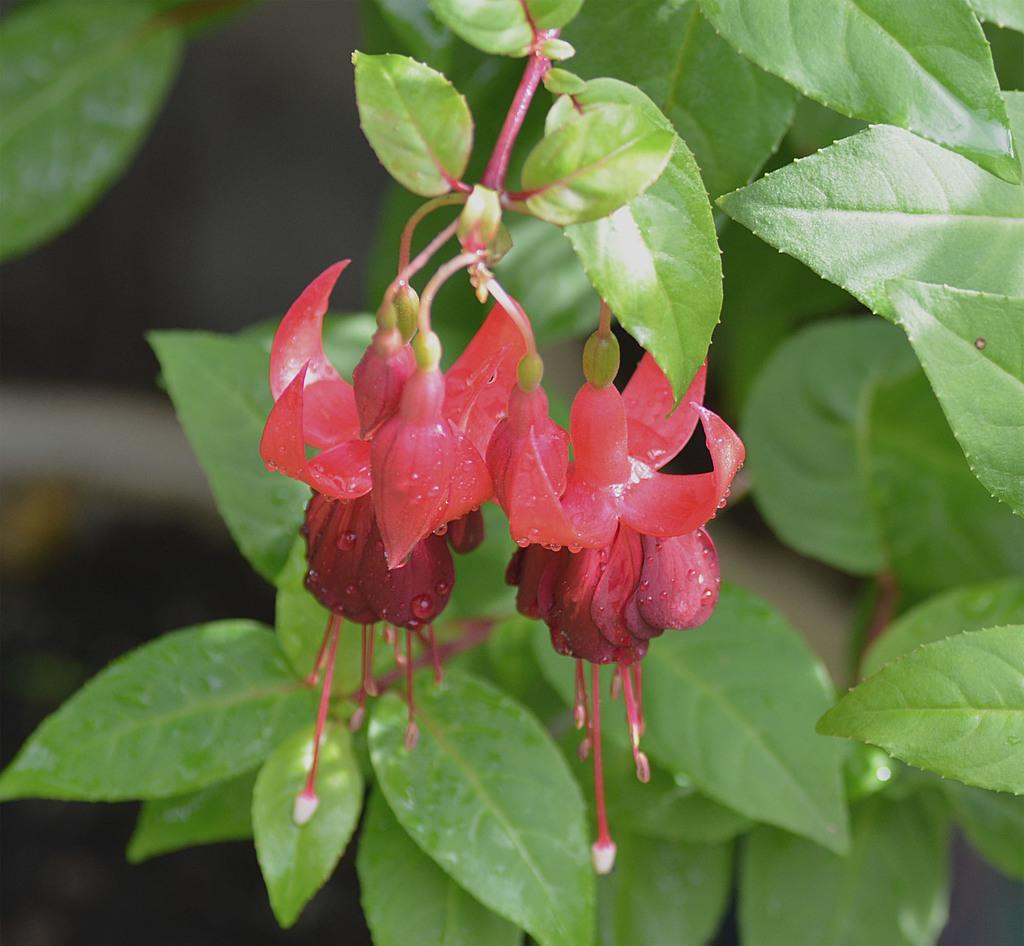Can you describe this image briefly? Here we can see flowers and leaves. Background it is blur. 